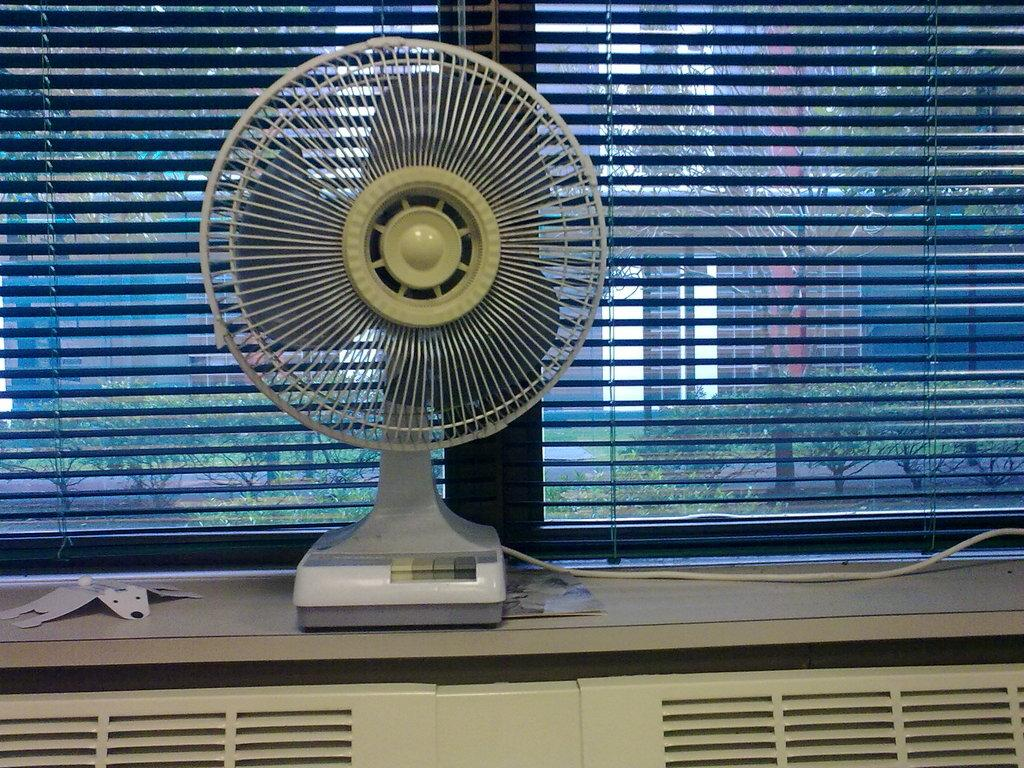What type of device is present in the image? There is a table fan in the image. What is the table fan placed on? The table fan is on a wooden platform. Does the table fan have any visible cords or cables? Yes, the table fan has a cable. What can be seen through the window in the image? Trees and buildings are visible behind the window. Is there any window treatment present in the image? Yes, there is a curtain on the window. What type of chicken is sitting on the table fan in the image? There is no chicken present in the image; it features a table fan on a wooden platform with a cable. How many cherries are on the table fan in the image? There are no cherries present in the image; it features a table fan on a wooden platform with a cable. 